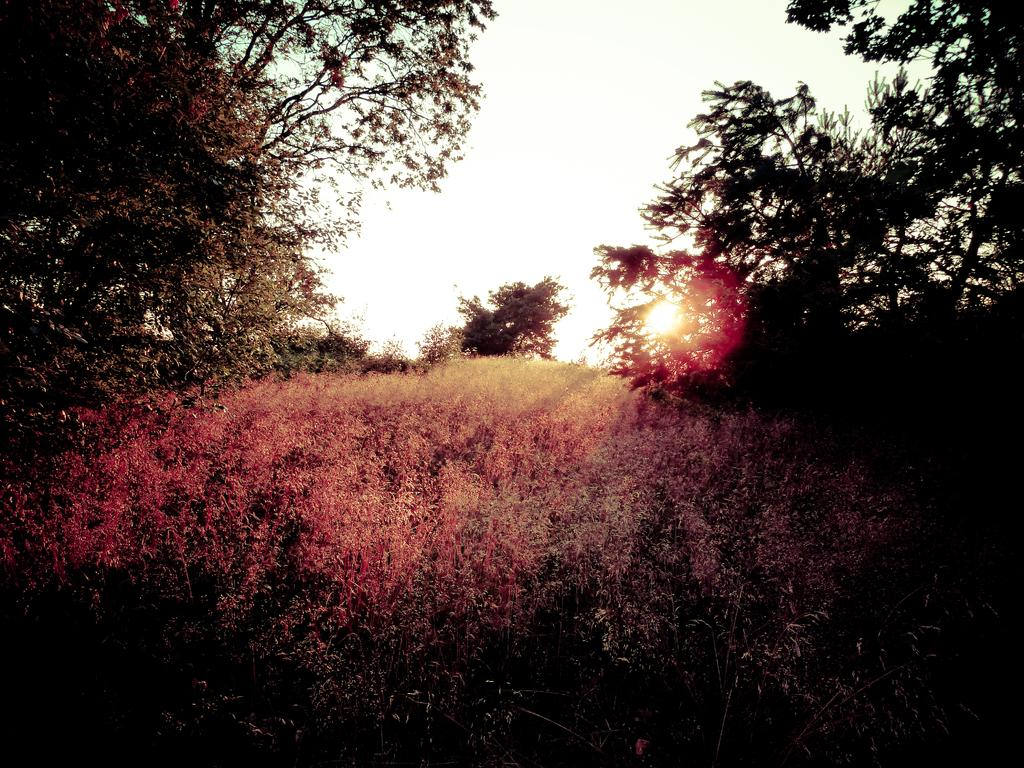What type of vegetation is at the bottom of the picture? There is grass at the bottom of the picture. What can be seen on either side of the picture? There are trees on either side of the picture. What is visible at the top of the picture? The sky is visible at the top of the picture. What celestial body is visible in the sky? The sun is visible in the sky. What type of canvas is being used to paint the trees in the image? There is no indication in the image that the trees are being painted, and therefore no canvas is present. How does the water flow through the grass in the image? There is no water present in the image, so it cannot flow through the grass. 